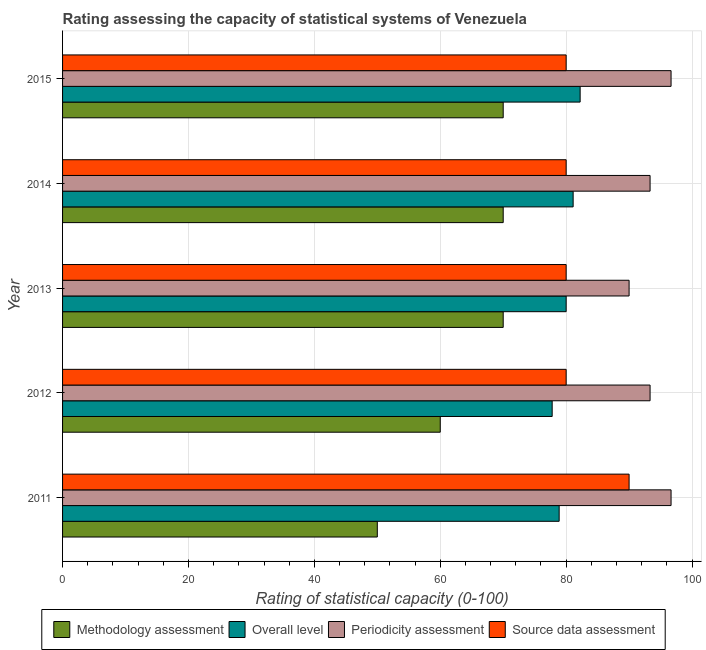Are the number of bars per tick equal to the number of legend labels?
Your response must be concise. Yes. Are the number of bars on each tick of the Y-axis equal?
Offer a very short reply. Yes. How many bars are there on the 2nd tick from the top?
Keep it short and to the point. 4. How many bars are there on the 4th tick from the bottom?
Provide a succinct answer. 4. What is the label of the 2nd group of bars from the top?
Make the answer very short. 2014. What is the overall level rating in 2015?
Provide a short and direct response. 82.22. Across all years, what is the maximum overall level rating?
Offer a terse response. 82.22. Across all years, what is the minimum overall level rating?
Provide a short and direct response. 77.78. In which year was the overall level rating minimum?
Your answer should be compact. 2012. What is the total overall level rating in the graph?
Provide a short and direct response. 400. What is the difference between the methodology assessment rating in 2015 and the source data assessment rating in 2013?
Ensure brevity in your answer.  -10. In the year 2015, what is the difference between the source data assessment rating and methodology assessment rating?
Offer a very short reply. 10. In how many years, is the methodology assessment rating greater than 4 ?
Offer a terse response. 5. What is the ratio of the source data assessment rating in 2011 to that in 2012?
Your answer should be compact. 1.12. Is the source data assessment rating in 2013 less than that in 2015?
Keep it short and to the point. No. Is the difference between the periodicity assessment rating in 2012 and 2015 greater than the difference between the methodology assessment rating in 2012 and 2015?
Provide a succinct answer. Yes. What is the difference between the highest and the lowest overall level rating?
Your answer should be very brief. 4.44. Is it the case that in every year, the sum of the periodicity assessment rating and source data assessment rating is greater than the sum of overall level rating and methodology assessment rating?
Provide a short and direct response. Yes. What does the 4th bar from the top in 2013 represents?
Give a very brief answer. Methodology assessment. What does the 4th bar from the bottom in 2013 represents?
Keep it short and to the point. Source data assessment. Is it the case that in every year, the sum of the methodology assessment rating and overall level rating is greater than the periodicity assessment rating?
Make the answer very short. Yes. Are all the bars in the graph horizontal?
Offer a very short reply. Yes. What is the difference between two consecutive major ticks on the X-axis?
Offer a very short reply. 20. Are the values on the major ticks of X-axis written in scientific E-notation?
Your answer should be very brief. No. Does the graph contain any zero values?
Your answer should be compact. No. Does the graph contain grids?
Your response must be concise. Yes. Where does the legend appear in the graph?
Your answer should be compact. Bottom center. How many legend labels are there?
Provide a succinct answer. 4. What is the title of the graph?
Your answer should be very brief. Rating assessing the capacity of statistical systems of Venezuela. What is the label or title of the X-axis?
Your response must be concise. Rating of statistical capacity (0-100). What is the label or title of the Y-axis?
Provide a short and direct response. Year. What is the Rating of statistical capacity (0-100) in Methodology assessment in 2011?
Your answer should be compact. 50. What is the Rating of statistical capacity (0-100) in Overall level in 2011?
Provide a short and direct response. 78.89. What is the Rating of statistical capacity (0-100) of Periodicity assessment in 2011?
Ensure brevity in your answer.  96.67. What is the Rating of statistical capacity (0-100) of Source data assessment in 2011?
Your answer should be very brief. 90. What is the Rating of statistical capacity (0-100) of Overall level in 2012?
Your answer should be very brief. 77.78. What is the Rating of statistical capacity (0-100) in Periodicity assessment in 2012?
Offer a terse response. 93.33. What is the Rating of statistical capacity (0-100) of Methodology assessment in 2013?
Keep it short and to the point. 70. What is the Rating of statistical capacity (0-100) of Overall level in 2013?
Offer a terse response. 80. What is the Rating of statistical capacity (0-100) of Source data assessment in 2013?
Make the answer very short. 80. What is the Rating of statistical capacity (0-100) in Methodology assessment in 2014?
Offer a very short reply. 70. What is the Rating of statistical capacity (0-100) in Overall level in 2014?
Provide a short and direct response. 81.11. What is the Rating of statistical capacity (0-100) of Periodicity assessment in 2014?
Offer a very short reply. 93.33. What is the Rating of statistical capacity (0-100) of Source data assessment in 2014?
Make the answer very short. 80. What is the Rating of statistical capacity (0-100) of Overall level in 2015?
Your response must be concise. 82.22. What is the Rating of statistical capacity (0-100) in Periodicity assessment in 2015?
Give a very brief answer. 96.67. Across all years, what is the maximum Rating of statistical capacity (0-100) in Overall level?
Make the answer very short. 82.22. Across all years, what is the maximum Rating of statistical capacity (0-100) in Periodicity assessment?
Provide a short and direct response. 96.67. Across all years, what is the maximum Rating of statistical capacity (0-100) of Source data assessment?
Your response must be concise. 90. Across all years, what is the minimum Rating of statistical capacity (0-100) in Overall level?
Offer a terse response. 77.78. Across all years, what is the minimum Rating of statistical capacity (0-100) in Source data assessment?
Offer a terse response. 80. What is the total Rating of statistical capacity (0-100) of Methodology assessment in the graph?
Offer a terse response. 320. What is the total Rating of statistical capacity (0-100) of Periodicity assessment in the graph?
Provide a succinct answer. 470. What is the total Rating of statistical capacity (0-100) of Source data assessment in the graph?
Keep it short and to the point. 410. What is the difference between the Rating of statistical capacity (0-100) in Overall level in 2011 and that in 2012?
Your response must be concise. 1.11. What is the difference between the Rating of statistical capacity (0-100) in Periodicity assessment in 2011 and that in 2012?
Provide a short and direct response. 3.33. What is the difference between the Rating of statistical capacity (0-100) of Source data assessment in 2011 and that in 2012?
Keep it short and to the point. 10. What is the difference between the Rating of statistical capacity (0-100) of Overall level in 2011 and that in 2013?
Provide a succinct answer. -1.11. What is the difference between the Rating of statistical capacity (0-100) of Source data assessment in 2011 and that in 2013?
Provide a succinct answer. 10. What is the difference between the Rating of statistical capacity (0-100) of Overall level in 2011 and that in 2014?
Ensure brevity in your answer.  -2.22. What is the difference between the Rating of statistical capacity (0-100) of Periodicity assessment in 2011 and that in 2014?
Make the answer very short. 3.33. What is the difference between the Rating of statistical capacity (0-100) of Source data assessment in 2011 and that in 2014?
Provide a succinct answer. 10. What is the difference between the Rating of statistical capacity (0-100) of Overall level in 2011 and that in 2015?
Make the answer very short. -3.33. What is the difference between the Rating of statistical capacity (0-100) of Periodicity assessment in 2011 and that in 2015?
Ensure brevity in your answer.  -0. What is the difference between the Rating of statistical capacity (0-100) of Source data assessment in 2011 and that in 2015?
Give a very brief answer. 10. What is the difference between the Rating of statistical capacity (0-100) of Methodology assessment in 2012 and that in 2013?
Your response must be concise. -10. What is the difference between the Rating of statistical capacity (0-100) in Overall level in 2012 and that in 2013?
Provide a succinct answer. -2.22. What is the difference between the Rating of statistical capacity (0-100) of Periodicity assessment in 2012 and that in 2013?
Your answer should be very brief. 3.33. What is the difference between the Rating of statistical capacity (0-100) in Source data assessment in 2012 and that in 2013?
Offer a very short reply. 0. What is the difference between the Rating of statistical capacity (0-100) in Methodology assessment in 2012 and that in 2014?
Give a very brief answer. -10. What is the difference between the Rating of statistical capacity (0-100) in Overall level in 2012 and that in 2014?
Offer a very short reply. -3.33. What is the difference between the Rating of statistical capacity (0-100) in Periodicity assessment in 2012 and that in 2014?
Offer a terse response. -0. What is the difference between the Rating of statistical capacity (0-100) in Source data assessment in 2012 and that in 2014?
Offer a terse response. 0. What is the difference between the Rating of statistical capacity (0-100) of Methodology assessment in 2012 and that in 2015?
Offer a terse response. -10. What is the difference between the Rating of statistical capacity (0-100) in Overall level in 2012 and that in 2015?
Offer a very short reply. -4.44. What is the difference between the Rating of statistical capacity (0-100) in Periodicity assessment in 2012 and that in 2015?
Keep it short and to the point. -3.33. What is the difference between the Rating of statistical capacity (0-100) in Methodology assessment in 2013 and that in 2014?
Provide a short and direct response. 0. What is the difference between the Rating of statistical capacity (0-100) in Overall level in 2013 and that in 2014?
Your answer should be very brief. -1.11. What is the difference between the Rating of statistical capacity (0-100) of Source data assessment in 2013 and that in 2014?
Ensure brevity in your answer.  0. What is the difference between the Rating of statistical capacity (0-100) of Methodology assessment in 2013 and that in 2015?
Your response must be concise. 0. What is the difference between the Rating of statistical capacity (0-100) of Overall level in 2013 and that in 2015?
Your answer should be very brief. -2.22. What is the difference between the Rating of statistical capacity (0-100) of Periodicity assessment in 2013 and that in 2015?
Ensure brevity in your answer.  -6.67. What is the difference between the Rating of statistical capacity (0-100) of Source data assessment in 2013 and that in 2015?
Your answer should be very brief. 0. What is the difference between the Rating of statistical capacity (0-100) of Overall level in 2014 and that in 2015?
Give a very brief answer. -1.11. What is the difference between the Rating of statistical capacity (0-100) of Periodicity assessment in 2014 and that in 2015?
Offer a terse response. -3.33. What is the difference between the Rating of statistical capacity (0-100) in Source data assessment in 2014 and that in 2015?
Provide a succinct answer. 0. What is the difference between the Rating of statistical capacity (0-100) in Methodology assessment in 2011 and the Rating of statistical capacity (0-100) in Overall level in 2012?
Make the answer very short. -27.78. What is the difference between the Rating of statistical capacity (0-100) of Methodology assessment in 2011 and the Rating of statistical capacity (0-100) of Periodicity assessment in 2012?
Your answer should be very brief. -43.33. What is the difference between the Rating of statistical capacity (0-100) of Overall level in 2011 and the Rating of statistical capacity (0-100) of Periodicity assessment in 2012?
Your answer should be compact. -14.44. What is the difference between the Rating of statistical capacity (0-100) of Overall level in 2011 and the Rating of statistical capacity (0-100) of Source data assessment in 2012?
Offer a very short reply. -1.11. What is the difference between the Rating of statistical capacity (0-100) of Periodicity assessment in 2011 and the Rating of statistical capacity (0-100) of Source data assessment in 2012?
Your answer should be compact. 16.67. What is the difference between the Rating of statistical capacity (0-100) in Overall level in 2011 and the Rating of statistical capacity (0-100) in Periodicity assessment in 2013?
Give a very brief answer. -11.11. What is the difference between the Rating of statistical capacity (0-100) in Overall level in 2011 and the Rating of statistical capacity (0-100) in Source data assessment in 2013?
Ensure brevity in your answer.  -1.11. What is the difference between the Rating of statistical capacity (0-100) of Periodicity assessment in 2011 and the Rating of statistical capacity (0-100) of Source data assessment in 2013?
Your answer should be very brief. 16.67. What is the difference between the Rating of statistical capacity (0-100) of Methodology assessment in 2011 and the Rating of statistical capacity (0-100) of Overall level in 2014?
Make the answer very short. -31.11. What is the difference between the Rating of statistical capacity (0-100) in Methodology assessment in 2011 and the Rating of statistical capacity (0-100) in Periodicity assessment in 2014?
Ensure brevity in your answer.  -43.33. What is the difference between the Rating of statistical capacity (0-100) of Methodology assessment in 2011 and the Rating of statistical capacity (0-100) of Source data assessment in 2014?
Give a very brief answer. -30. What is the difference between the Rating of statistical capacity (0-100) of Overall level in 2011 and the Rating of statistical capacity (0-100) of Periodicity assessment in 2014?
Your answer should be compact. -14.44. What is the difference between the Rating of statistical capacity (0-100) in Overall level in 2011 and the Rating of statistical capacity (0-100) in Source data assessment in 2014?
Ensure brevity in your answer.  -1.11. What is the difference between the Rating of statistical capacity (0-100) in Periodicity assessment in 2011 and the Rating of statistical capacity (0-100) in Source data assessment in 2014?
Your answer should be compact. 16.67. What is the difference between the Rating of statistical capacity (0-100) of Methodology assessment in 2011 and the Rating of statistical capacity (0-100) of Overall level in 2015?
Provide a short and direct response. -32.22. What is the difference between the Rating of statistical capacity (0-100) of Methodology assessment in 2011 and the Rating of statistical capacity (0-100) of Periodicity assessment in 2015?
Provide a succinct answer. -46.67. What is the difference between the Rating of statistical capacity (0-100) in Overall level in 2011 and the Rating of statistical capacity (0-100) in Periodicity assessment in 2015?
Your response must be concise. -17.78. What is the difference between the Rating of statistical capacity (0-100) in Overall level in 2011 and the Rating of statistical capacity (0-100) in Source data assessment in 2015?
Make the answer very short. -1.11. What is the difference between the Rating of statistical capacity (0-100) of Periodicity assessment in 2011 and the Rating of statistical capacity (0-100) of Source data assessment in 2015?
Make the answer very short. 16.67. What is the difference between the Rating of statistical capacity (0-100) of Methodology assessment in 2012 and the Rating of statistical capacity (0-100) of Periodicity assessment in 2013?
Provide a succinct answer. -30. What is the difference between the Rating of statistical capacity (0-100) in Methodology assessment in 2012 and the Rating of statistical capacity (0-100) in Source data assessment in 2013?
Keep it short and to the point. -20. What is the difference between the Rating of statistical capacity (0-100) in Overall level in 2012 and the Rating of statistical capacity (0-100) in Periodicity assessment in 2013?
Keep it short and to the point. -12.22. What is the difference between the Rating of statistical capacity (0-100) in Overall level in 2012 and the Rating of statistical capacity (0-100) in Source data assessment in 2013?
Offer a very short reply. -2.22. What is the difference between the Rating of statistical capacity (0-100) of Periodicity assessment in 2012 and the Rating of statistical capacity (0-100) of Source data assessment in 2013?
Offer a terse response. 13.33. What is the difference between the Rating of statistical capacity (0-100) in Methodology assessment in 2012 and the Rating of statistical capacity (0-100) in Overall level in 2014?
Ensure brevity in your answer.  -21.11. What is the difference between the Rating of statistical capacity (0-100) of Methodology assessment in 2012 and the Rating of statistical capacity (0-100) of Periodicity assessment in 2014?
Your answer should be compact. -33.33. What is the difference between the Rating of statistical capacity (0-100) in Overall level in 2012 and the Rating of statistical capacity (0-100) in Periodicity assessment in 2014?
Keep it short and to the point. -15.56. What is the difference between the Rating of statistical capacity (0-100) in Overall level in 2012 and the Rating of statistical capacity (0-100) in Source data assessment in 2014?
Provide a short and direct response. -2.22. What is the difference between the Rating of statistical capacity (0-100) of Periodicity assessment in 2012 and the Rating of statistical capacity (0-100) of Source data assessment in 2014?
Keep it short and to the point. 13.33. What is the difference between the Rating of statistical capacity (0-100) in Methodology assessment in 2012 and the Rating of statistical capacity (0-100) in Overall level in 2015?
Keep it short and to the point. -22.22. What is the difference between the Rating of statistical capacity (0-100) in Methodology assessment in 2012 and the Rating of statistical capacity (0-100) in Periodicity assessment in 2015?
Keep it short and to the point. -36.67. What is the difference between the Rating of statistical capacity (0-100) in Methodology assessment in 2012 and the Rating of statistical capacity (0-100) in Source data assessment in 2015?
Your answer should be very brief. -20. What is the difference between the Rating of statistical capacity (0-100) of Overall level in 2012 and the Rating of statistical capacity (0-100) of Periodicity assessment in 2015?
Your answer should be very brief. -18.89. What is the difference between the Rating of statistical capacity (0-100) in Overall level in 2012 and the Rating of statistical capacity (0-100) in Source data assessment in 2015?
Your answer should be very brief. -2.22. What is the difference between the Rating of statistical capacity (0-100) in Periodicity assessment in 2012 and the Rating of statistical capacity (0-100) in Source data assessment in 2015?
Give a very brief answer. 13.33. What is the difference between the Rating of statistical capacity (0-100) in Methodology assessment in 2013 and the Rating of statistical capacity (0-100) in Overall level in 2014?
Ensure brevity in your answer.  -11.11. What is the difference between the Rating of statistical capacity (0-100) in Methodology assessment in 2013 and the Rating of statistical capacity (0-100) in Periodicity assessment in 2014?
Your response must be concise. -23.33. What is the difference between the Rating of statistical capacity (0-100) of Overall level in 2013 and the Rating of statistical capacity (0-100) of Periodicity assessment in 2014?
Offer a very short reply. -13.33. What is the difference between the Rating of statistical capacity (0-100) of Periodicity assessment in 2013 and the Rating of statistical capacity (0-100) of Source data assessment in 2014?
Offer a very short reply. 10. What is the difference between the Rating of statistical capacity (0-100) of Methodology assessment in 2013 and the Rating of statistical capacity (0-100) of Overall level in 2015?
Keep it short and to the point. -12.22. What is the difference between the Rating of statistical capacity (0-100) in Methodology assessment in 2013 and the Rating of statistical capacity (0-100) in Periodicity assessment in 2015?
Ensure brevity in your answer.  -26.67. What is the difference between the Rating of statistical capacity (0-100) of Methodology assessment in 2013 and the Rating of statistical capacity (0-100) of Source data assessment in 2015?
Give a very brief answer. -10. What is the difference between the Rating of statistical capacity (0-100) in Overall level in 2013 and the Rating of statistical capacity (0-100) in Periodicity assessment in 2015?
Provide a short and direct response. -16.67. What is the difference between the Rating of statistical capacity (0-100) of Methodology assessment in 2014 and the Rating of statistical capacity (0-100) of Overall level in 2015?
Give a very brief answer. -12.22. What is the difference between the Rating of statistical capacity (0-100) of Methodology assessment in 2014 and the Rating of statistical capacity (0-100) of Periodicity assessment in 2015?
Give a very brief answer. -26.67. What is the difference between the Rating of statistical capacity (0-100) in Methodology assessment in 2014 and the Rating of statistical capacity (0-100) in Source data assessment in 2015?
Keep it short and to the point. -10. What is the difference between the Rating of statistical capacity (0-100) of Overall level in 2014 and the Rating of statistical capacity (0-100) of Periodicity assessment in 2015?
Offer a terse response. -15.56. What is the difference between the Rating of statistical capacity (0-100) in Overall level in 2014 and the Rating of statistical capacity (0-100) in Source data assessment in 2015?
Keep it short and to the point. 1.11. What is the difference between the Rating of statistical capacity (0-100) of Periodicity assessment in 2014 and the Rating of statistical capacity (0-100) of Source data assessment in 2015?
Your answer should be very brief. 13.33. What is the average Rating of statistical capacity (0-100) of Methodology assessment per year?
Ensure brevity in your answer.  64. What is the average Rating of statistical capacity (0-100) of Periodicity assessment per year?
Make the answer very short. 94. In the year 2011, what is the difference between the Rating of statistical capacity (0-100) of Methodology assessment and Rating of statistical capacity (0-100) of Overall level?
Offer a very short reply. -28.89. In the year 2011, what is the difference between the Rating of statistical capacity (0-100) in Methodology assessment and Rating of statistical capacity (0-100) in Periodicity assessment?
Keep it short and to the point. -46.67. In the year 2011, what is the difference between the Rating of statistical capacity (0-100) of Methodology assessment and Rating of statistical capacity (0-100) of Source data assessment?
Offer a terse response. -40. In the year 2011, what is the difference between the Rating of statistical capacity (0-100) of Overall level and Rating of statistical capacity (0-100) of Periodicity assessment?
Keep it short and to the point. -17.78. In the year 2011, what is the difference between the Rating of statistical capacity (0-100) in Overall level and Rating of statistical capacity (0-100) in Source data assessment?
Ensure brevity in your answer.  -11.11. In the year 2012, what is the difference between the Rating of statistical capacity (0-100) in Methodology assessment and Rating of statistical capacity (0-100) in Overall level?
Ensure brevity in your answer.  -17.78. In the year 2012, what is the difference between the Rating of statistical capacity (0-100) of Methodology assessment and Rating of statistical capacity (0-100) of Periodicity assessment?
Give a very brief answer. -33.33. In the year 2012, what is the difference between the Rating of statistical capacity (0-100) of Methodology assessment and Rating of statistical capacity (0-100) of Source data assessment?
Your answer should be compact. -20. In the year 2012, what is the difference between the Rating of statistical capacity (0-100) in Overall level and Rating of statistical capacity (0-100) in Periodicity assessment?
Your answer should be very brief. -15.56. In the year 2012, what is the difference between the Rating of statistical capacity (0-100) of Overall level and Rating of statistical capacity (0-100) of Source data assessment?
Provide a short and direct response. -2.22. In the year 2012, what is the difference between the Rating of statistical capacity (0-100) in Periodicity assessment and Rating of statistical capacity (0-100) in Source data assessment?
Provide a succinct answer. 13.33. In the year 2013, what is the difference between the Rating of statistical capacity (0-100) in Methodology assessment and Rating of statistical capacity (0-100) in Periodicity assessment?
Offer a very short reply. -20. In the year 2013, what is the difference between the Rating of statistical capacity (0-100) in Overall level and Rating of statistical capacity (0-100) in Periodicity assessment?
Offer a very short reply. -10. In the year 2014, what is the difference between the Rating of statistical capacity (0-100) in Methodology assessment and Rating of statistical capacity (0-100) in Overall level?
Make the answer very short. -11.11. In the year 2014, what is the difference between the Rating of statistical capacity (0-100) in Methodology assessment and Rating of statistical capacity (0-100) in Periodicity assessment?
Make the answer very short. -23.33. In the year 2014, what is the difference between the Rating of statistical capacity (0-100) in Overall level and Rating of statistical capacity (0-100) in Periodicity assessment?
Provide a succinct answer. -12.22. In the year 2014, what is the difference between the Rating of statistical capacity (0-100) in Periodicity assessment and Rating of statistical capacity (0-100) in Source data assessment?
Make the answer very short. 13.33. In the year 2015, what is the difference between the Rating of statistical capacity (0-100) in Methodology assessment and Rating of statistical capacity (0-100) in Overall level?
Offer a very short reply. -12.22. In the year 2015, what is the difference between the Rating of statistical capacity (0-100) in Methodology assessment and Rating of statistical capacity (0-100) in Periodicity assessment?
Ensure brevity in your answer.  -26.67. In the year 2015, what is the difference between the Rating of statistical capacity (0-100) of Methodology assessment and Rating of statistical capacity (0-100) of Source data assessment?
Provide a succinct answer. -10. In the year 2015, what is the difference between the Rating of statistical capacity (0-100) of Overall level and Rating of statistical capacity (0-100) of Periodicity assessment?
Provide a short and direct response. -14.44. In the year 2015, what is the difference between the Rating of statistical capacity (0-100) in Overall level and Rating of statistical capacity (0-100) in Source data assessment?
Provide a succinct answer. 2.22. In the year 2015, what is the difference between the Rating of statistical capacity (0-100) in Periodicity assessment and Rating of statistical capacity (0-100) in Source data assessment?
Offer a terse response. 16.67. What is the ratio of the Rating of statistical capacity (0-100) of Overall level in 2011 to that in 2012?
Give a very brief answer. 1.01. What is the ratio of the Rating of statistical capacity (0-100) in Periodicity assessment in 2011 to that in 2012?
Offer a very short reply. 1.04. What is the ratio of the Rating of statistical capacity (0-100) in Source data assessment in 2011 to that in 2012?
Offer a terse response. 1.12. What is the ratio of the Rating of statistical capacity (0-100) of Overall level in 2011 to that in 2013?
Give a very brief answer. 0.99. What is the ratio of the Rating of statistical capacity (0-100) in Periodicity assessment in 2011 to that in 2013?
Give a very brief answer. 1.07. What is the ratio of the Rating of statistical capacity (0-100) of Source data assessment in 2011 to that in 2013?
Offer a very short reply. 1.12. What is the ratio of the Rating of statistical capacity (0-100) of Overall level in 2011 to that in 2014?
Your answer should be very brief. 0.97. What is the ratio of the Rating of statistical capacity (0-100) of Periodicity assessment in 2011 to that in 2014?
Provide a succinct answer. 1.04. What is the ratio of the Rating of statistical capacity (0-100) in Methodology assessment in 2011 to that in 2015?
Your response must be concise. 0.71. What is the ratio of the Rating of statistical capacity (0-100) of Overall level in 2011 to that in 2015?
Give a very brief answer. 0.96. What is the ratio of the Rating of statistical capacity (0-100) in Source data assessment in 2011 to that in 2015?
Keep it short and to the point. 1.12. What is the ratio of the Rating of statistical capacity (0-100) in Overall level in 2012 to that in 2013?
Give a very brief answer. 0.97. What is the ratio of the Rating of statistical capacity (0-100) in Source data assessment in 2012 to that in 2013?
Provide a short and direct response. 1. What is the ratio of the Rating of statistical capacity (0-100) of Methodology assessment in 2012 to that in 2014?
Your response must be concise. 0.86. What is the ratio of the Rating of statistical capacity (0-100) in Overall level in 2012 to that in 2014?
Your response must be concise. 0.96. What is the ratio of the Rating of statistical capacity (0-100) of Periodicity assessment in 2012 to that in 2014?
Ensure brevity in your answer.  1. What is the ratio of the Rating of statistical capacity (0-100) of Source data assessment in 2012 to that in 2014?
Keep it short and to the point. 1. What is the ratio of the Rating of statistical capacity (0-100) in Overall level in 2012 to that in 2015?
Your answer should be compact. 0.95. What is the ratio of the Rating of statistical capacity (0-100) in Periodicity assessment in 2012 to that in 2015?
Your answer should be compact. 0.97. What is the ratio of the Rating of statistical capacity (0-100) of Source data assessment in 2012 to that in 2015?
Give a very brief answer. 1. What is the ratio of the Rating of statistical capacity (0-100) in Overall level in 2013 to that in 2014?
Your answer should be compact. 0.99. What is the ratio of the Rating of statistical capacity (0-100) in Periodicity assessment in 2013 to that in 2014?
Keep it short and to the point. 0.96. What is the ratio of the Rating of statistical capacity (0-100) of Methodology assessment in 2013 to that in 2015?
Your answer should be very brief. 1. What is the ratio of the Rating of statistical capacity (0-100) in Overall level in 2013 to that in 2015?
Your answer should be compact. 0.97. What is the ratio of the Rating of statistical capacity (0-100) in Methodology assessment in 2014 to that in 2015?
Your answer should be compact. 1. What is the ratio of the Rating of statistical capacity (0-100) in Overall level in 2014 to that in 2015?
Provide a succinct answer. 0.99. What is the ratio of the Rating of statistical capacity (0-100) in Periodicity assessment in 2014 to that in 2015?
Provide a succinct answer. 0.97. What is the ratio of the Rating of statistical capacity (0-100) in Source data assessment in 2014 to that in 2015?
Provide a short and direct response. 1. What is the difference between the highest and the second highest Rating of statistical capacity (0-100) of Methodology assessment?
Provide a succinct answer. 0. What is the difference between the highest and the second highest Rating of statistical capacity (0-100) in Overall level?
Provide a short and direct response. 1.11. What is the difference between the highest and the second highest Rating of statistical capacity (0-100) in Periodicity assessment?
Offer a terse response. 0. What is the difference between the highest and the second highest Rating of statistical capacity (0-100) in Source data assessment?
Ensure brevity in your answer.  10. What is the difference between the highest and the lowest Rating of statistical capacity (0-100) in Overall level?
Offer a terse response. 4.44. What is the difference between the highest and the lowest Rating of statistical capacity (0-100) in Periodicity assessment?
Provide a succinct answer. 6.67. What is the difference between the highest and the lowest Rating of statistical capacity (0-100) in Source data assessment?
Provide a succinct answer. 10. 